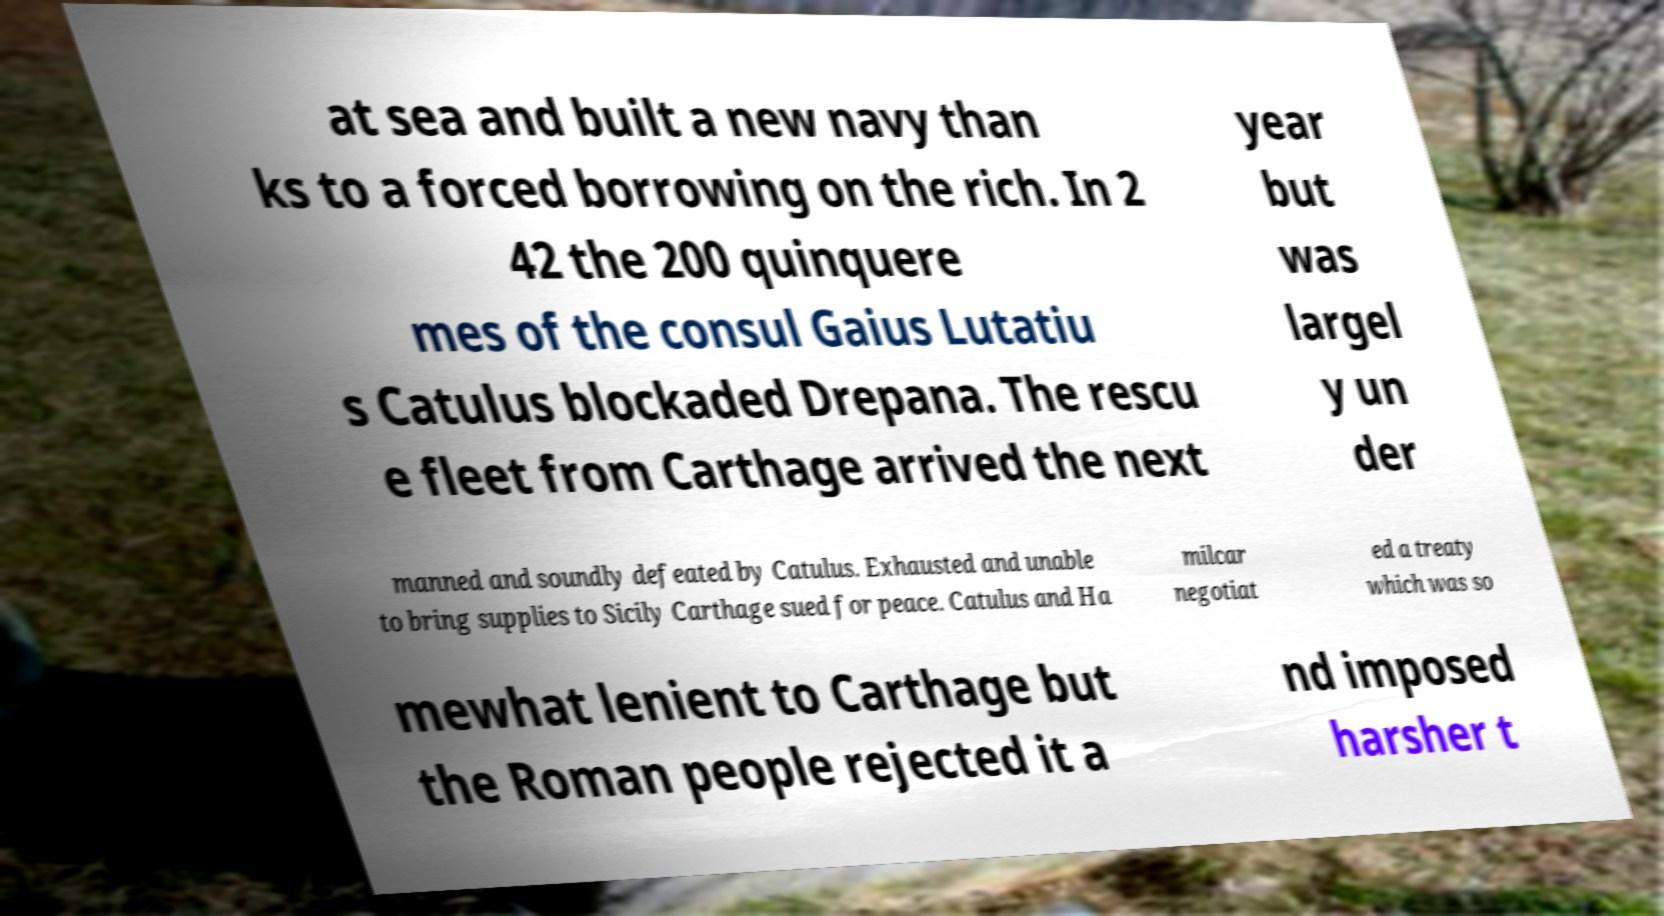I need the written content from this picture converted into text. Can you do that? at sea and built a new navy than ks to a forced borrowing on the rich. In 2 42 the 200 quinquere mes of the consul Gaius Lutatiu s Catulus blockaded Drepana. The rescu e fleet from Carthage arrived the next year but was largel y un der manned and soundly defeated by Catulus. Exhausted and unable to bring supplies to Sicily Carthage sued for peace. Catulus and Ha milcar negotiat ed a treaty which was so mewhat lenient to Carthage but the Roman people rejected it a nd imposed harsher t 